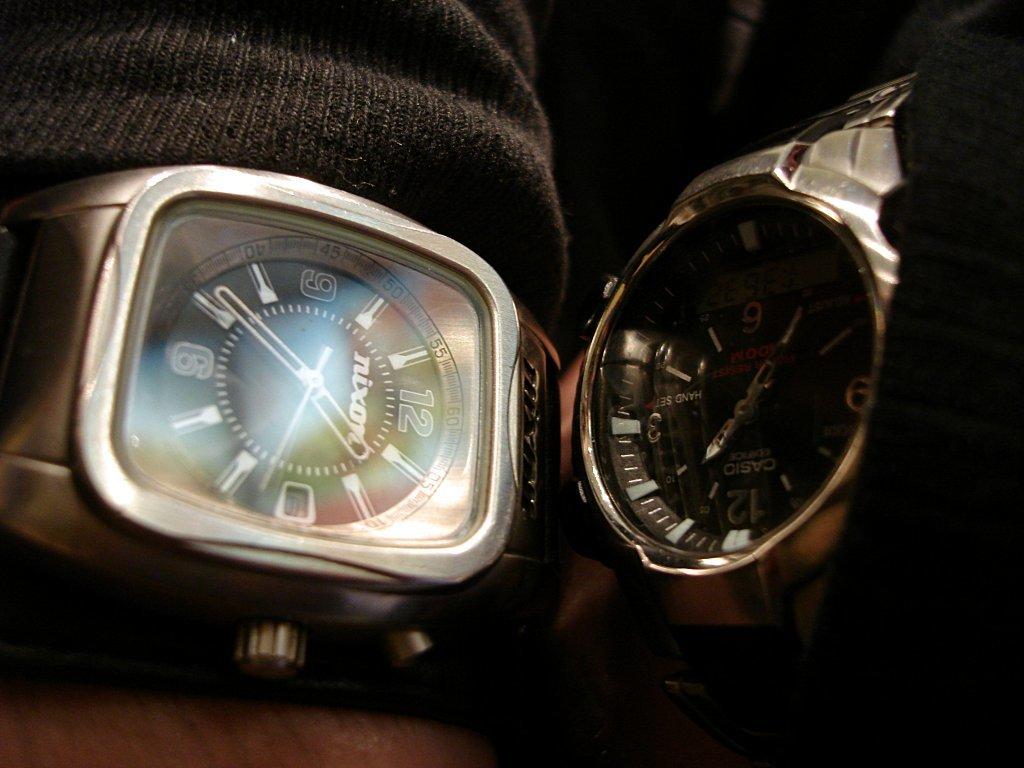What brand is the watch on the right?
Give a very brief answer. Casio. What brand is the watch on the left?
Provide a succinct answer. Nixon. 